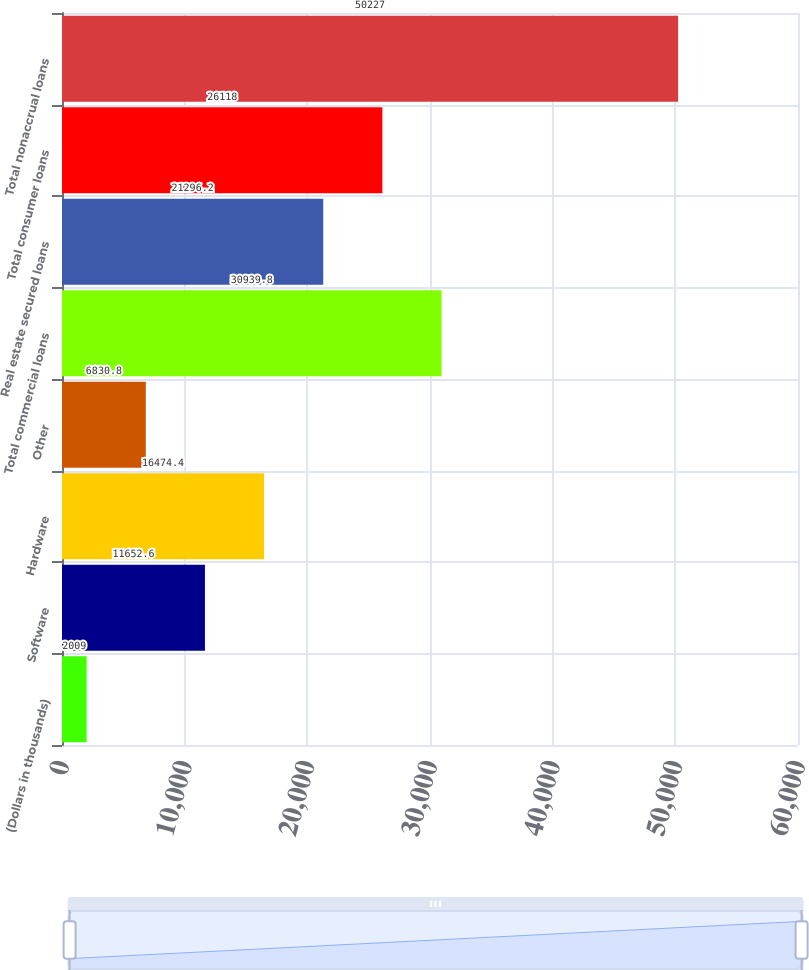Convert chart. <chart><loc_0><loc_0><loc_500><loc_500><bar_chart><fcel>(Dollars in thousands)<fcel>Software<fcel>Hardware<fcel>Other<fcel>Total commercial loans<fcel>Real estate secured loans<fcel>Total consumer loans<fcel>Total nonaccrual loans<nl><fcel>2009<fcel>11652.6<fcel>16474.4<fcel>6830.8<fcel>30939.8<fcel>21296.2<fcel>26118<fcel>50227<nl></chart> 